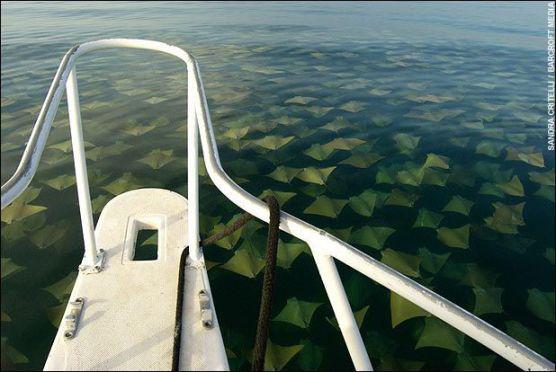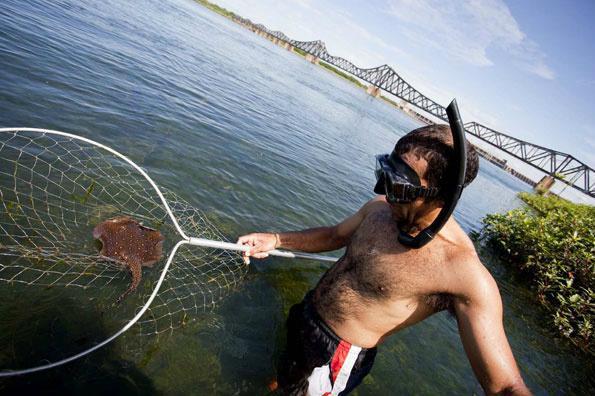The first image is the image on the left, the second image is the image on the right. Analyze the images presented: Is the assertion "One stingray with a spotted pattern is included in the right image." valid? Answer yes or no. Yes. 